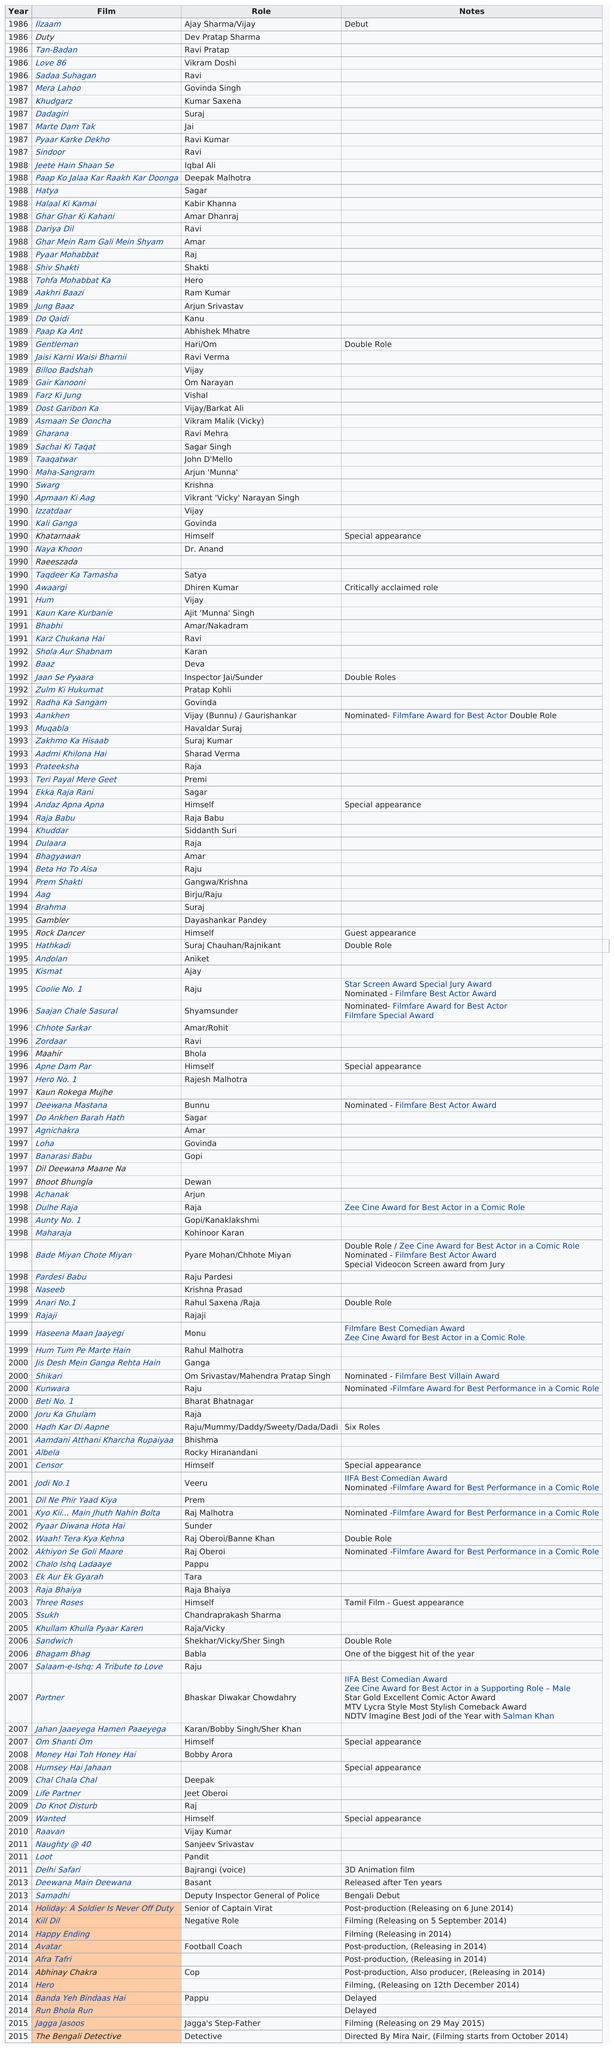Point out several critical features in this image. After starring in the movie "Dadagiri", the actor played the role of a father who sacrifices his life to save his child in "Marte Dam Tak...". The film that followed Love 86 was Sadaa Suhagan... The last time Ravi appeared on the list was in 1996. Govinda made his film debut in the movie "Ilzaam" in which he appeared as a lead actor. The only year with a critically acclaimed role was 1990. 